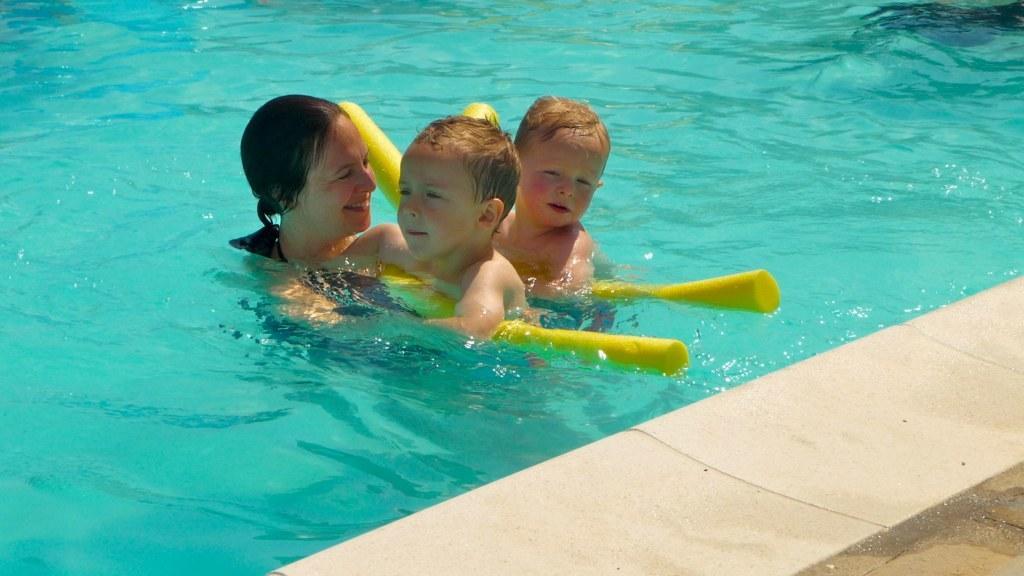Please provide a concise description of this image. In this image, there are three people in the water and holding the objects. At the bottom right side of the image, I can see the pathway. 